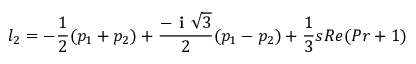Convert formula to latex. <formula><loc_0><loc_0><loc_500><loc_500>l _ { 2 } = - \frac { 1 } { 2 } ( p _ { 1 } + p _ { 2 } ) + \frac { - i \sqrt { 3 } } { 2 } ( p _ { 1 } - p _ { 2 } ) + \frac { 1 } { 3 } s R e ( P r + 1 )</formula> 